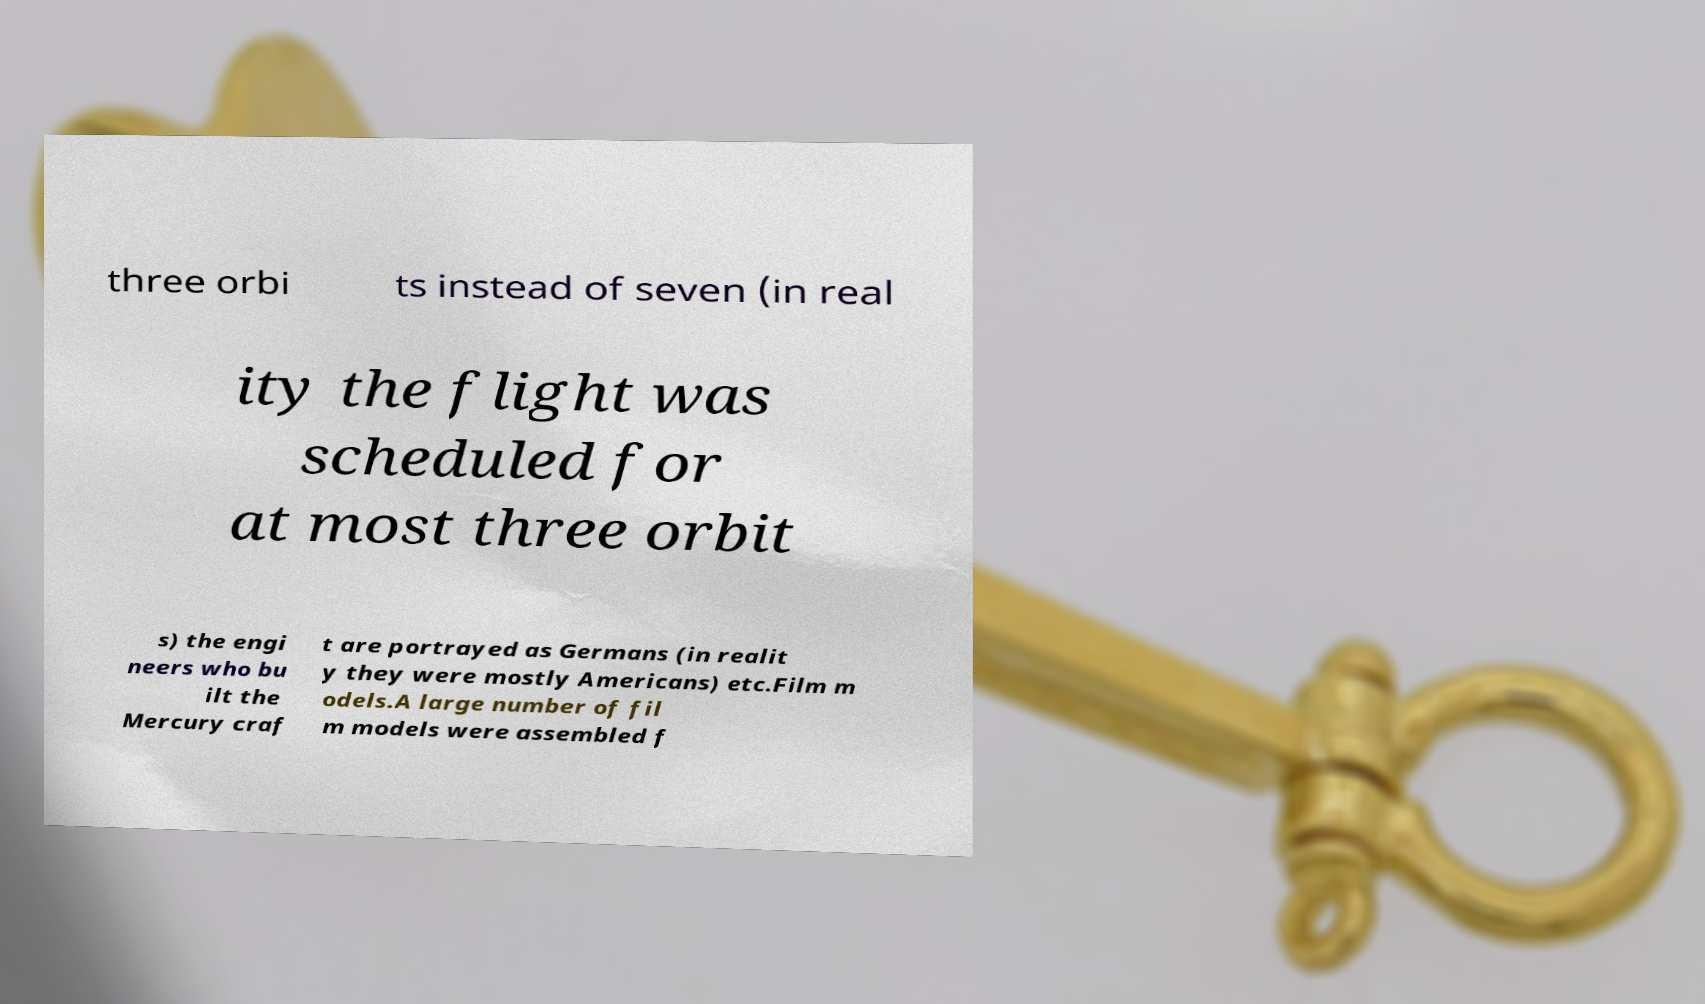Could you assist in decoding the text presented in this image and type it out clearly? three orbi ts instead of seven (in real ity the flight was scheduled for at most three orbit s) the engi neers who bu ilt the Mercury craf t are portrayed as Germans (in realit y they were mostly Americans) etc.Film m odels.A large number of fil m models were assembled f 